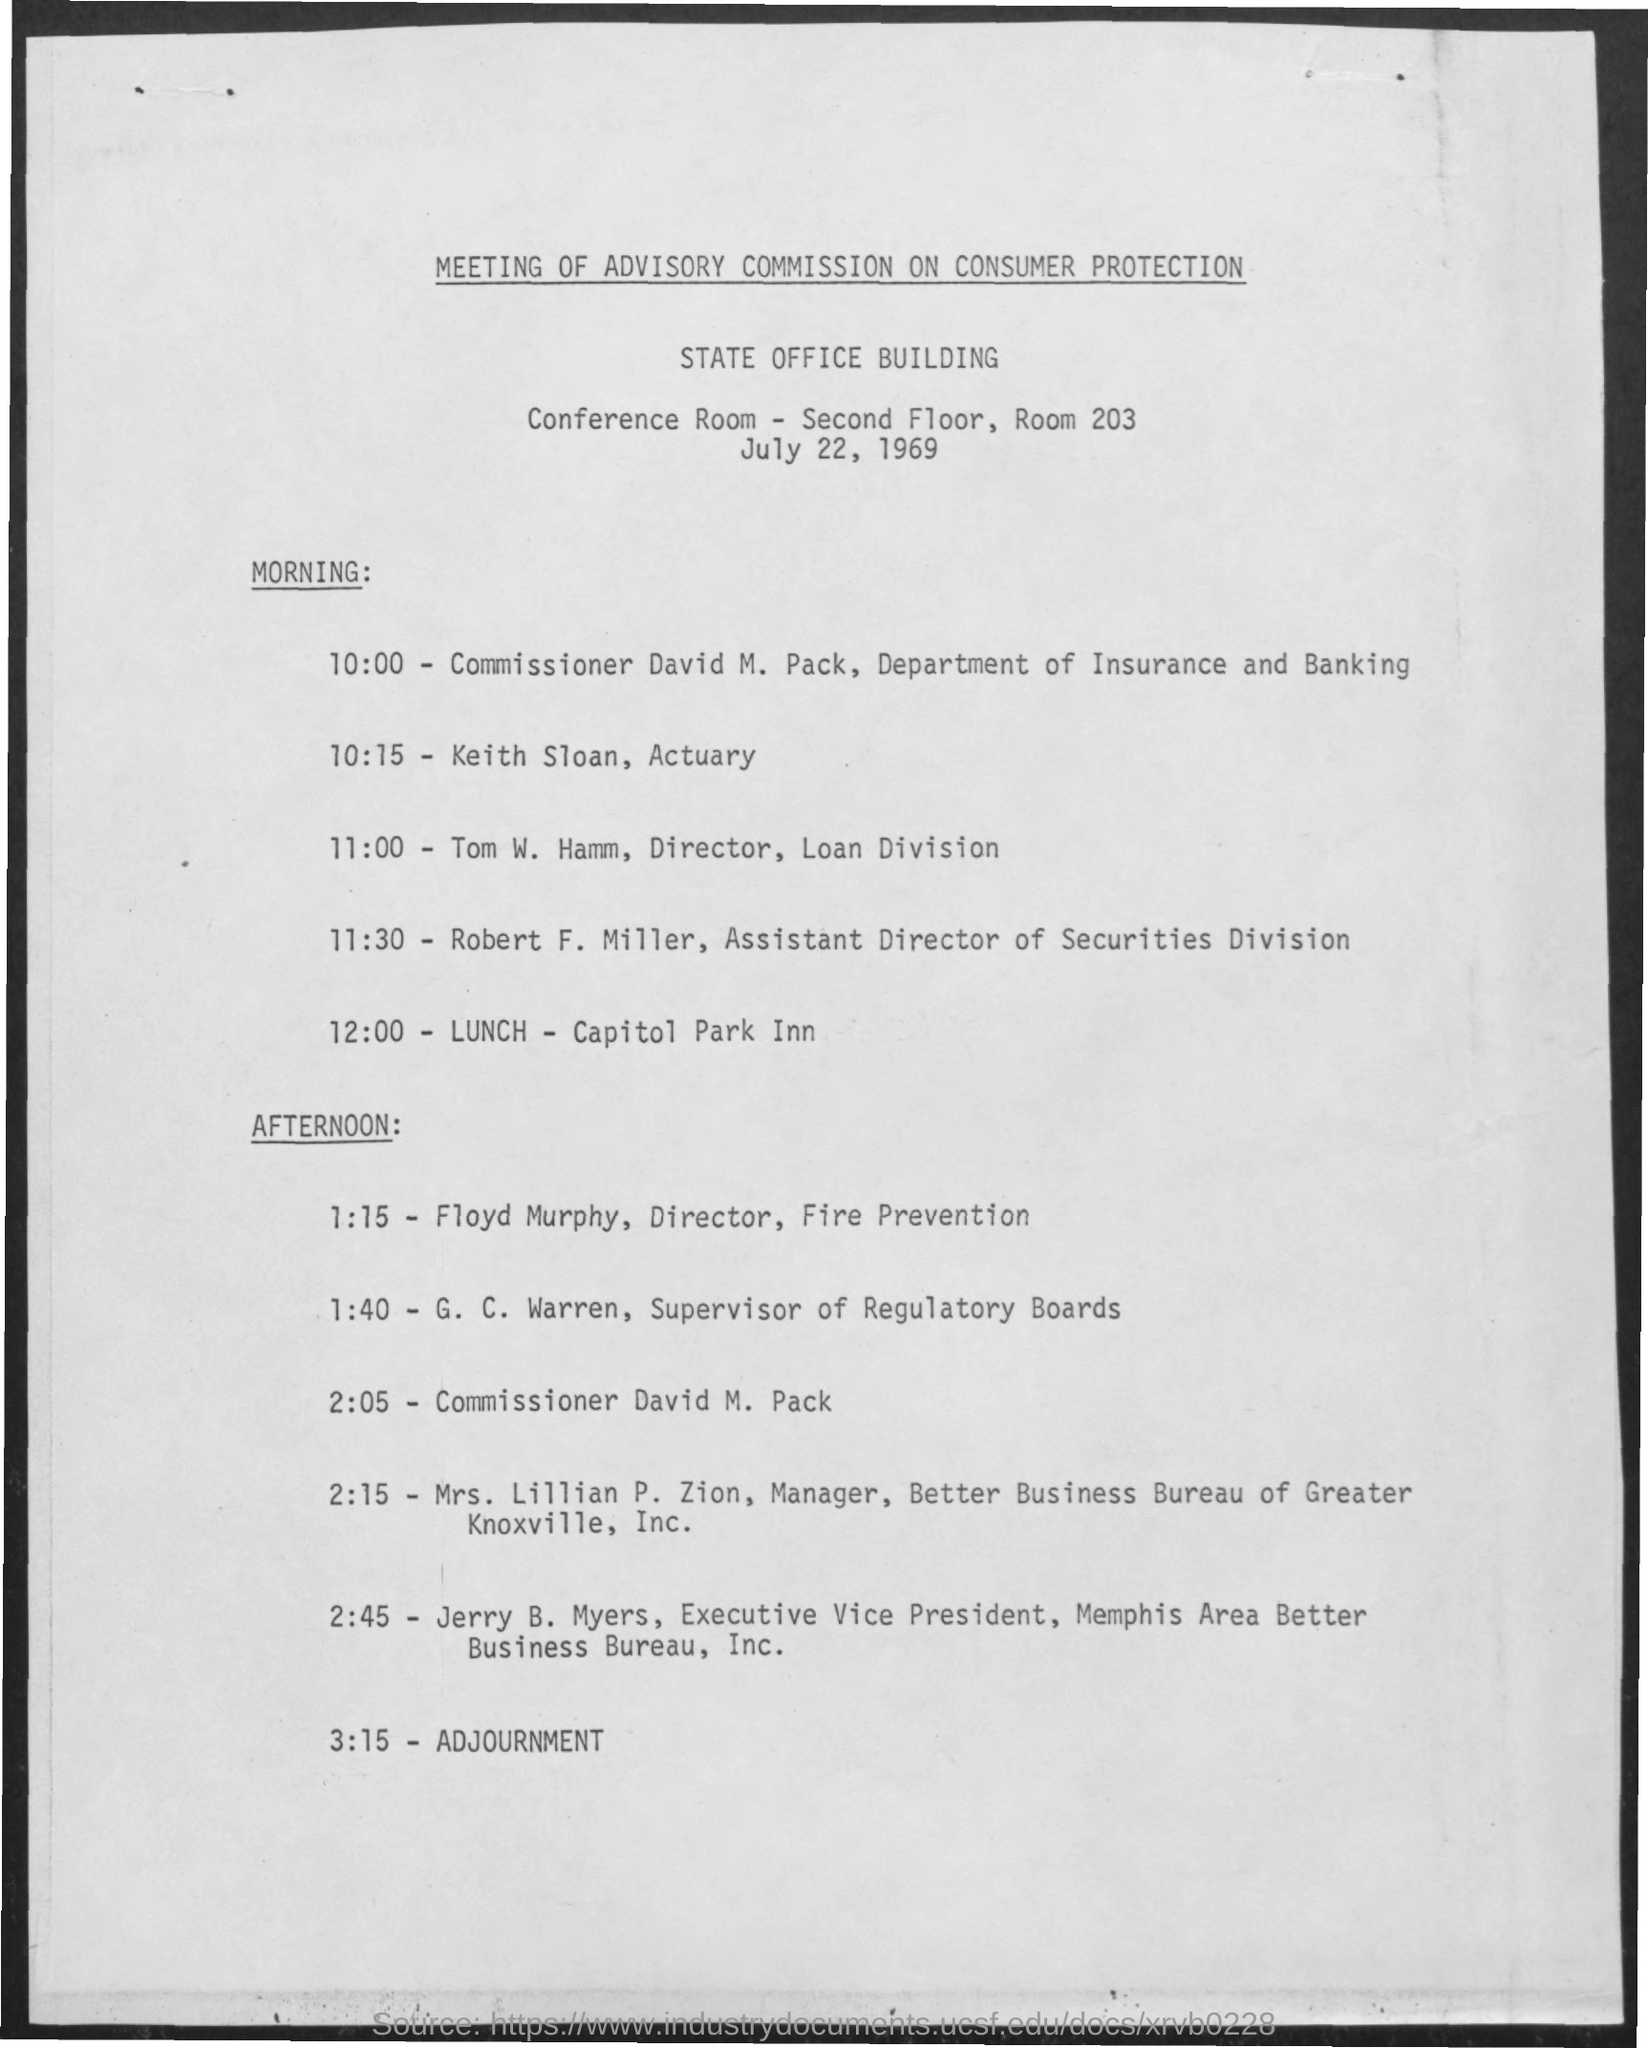What is the significance of the Advisory Commission on Consumer Protection? The Advisory Commission on Consumer Protection is likely a governmental body tasked with overseeing and advising on matters related to consumer rights and safeguards. The commission would be responsible for evaluating consumer protection policies, making recommendations for improvements, and possibly enforcing consumer laws. 